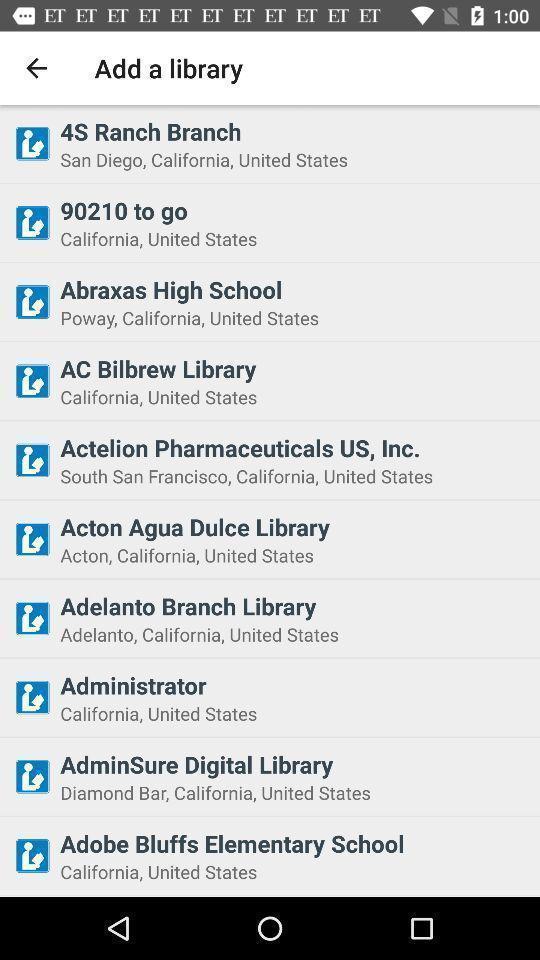Provide a textual representation of this image. Screen displaying the library page. 